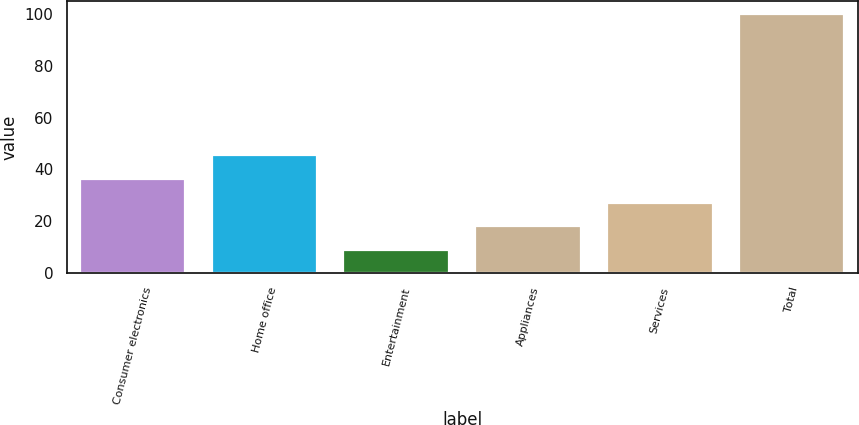<chart> <loc_0><loc_0><loc_500><loc_500><bar_chart><fcel>Consumer electronics<fcel>Home office<fcel>Entertainment<fcel>Appliances<fcel>Services<fcel>Total<nl><fcel>36.3<fcel>45.4<fcel>9<fcel>18.1<fcel>27.2<fcel>100<nl></chart> 